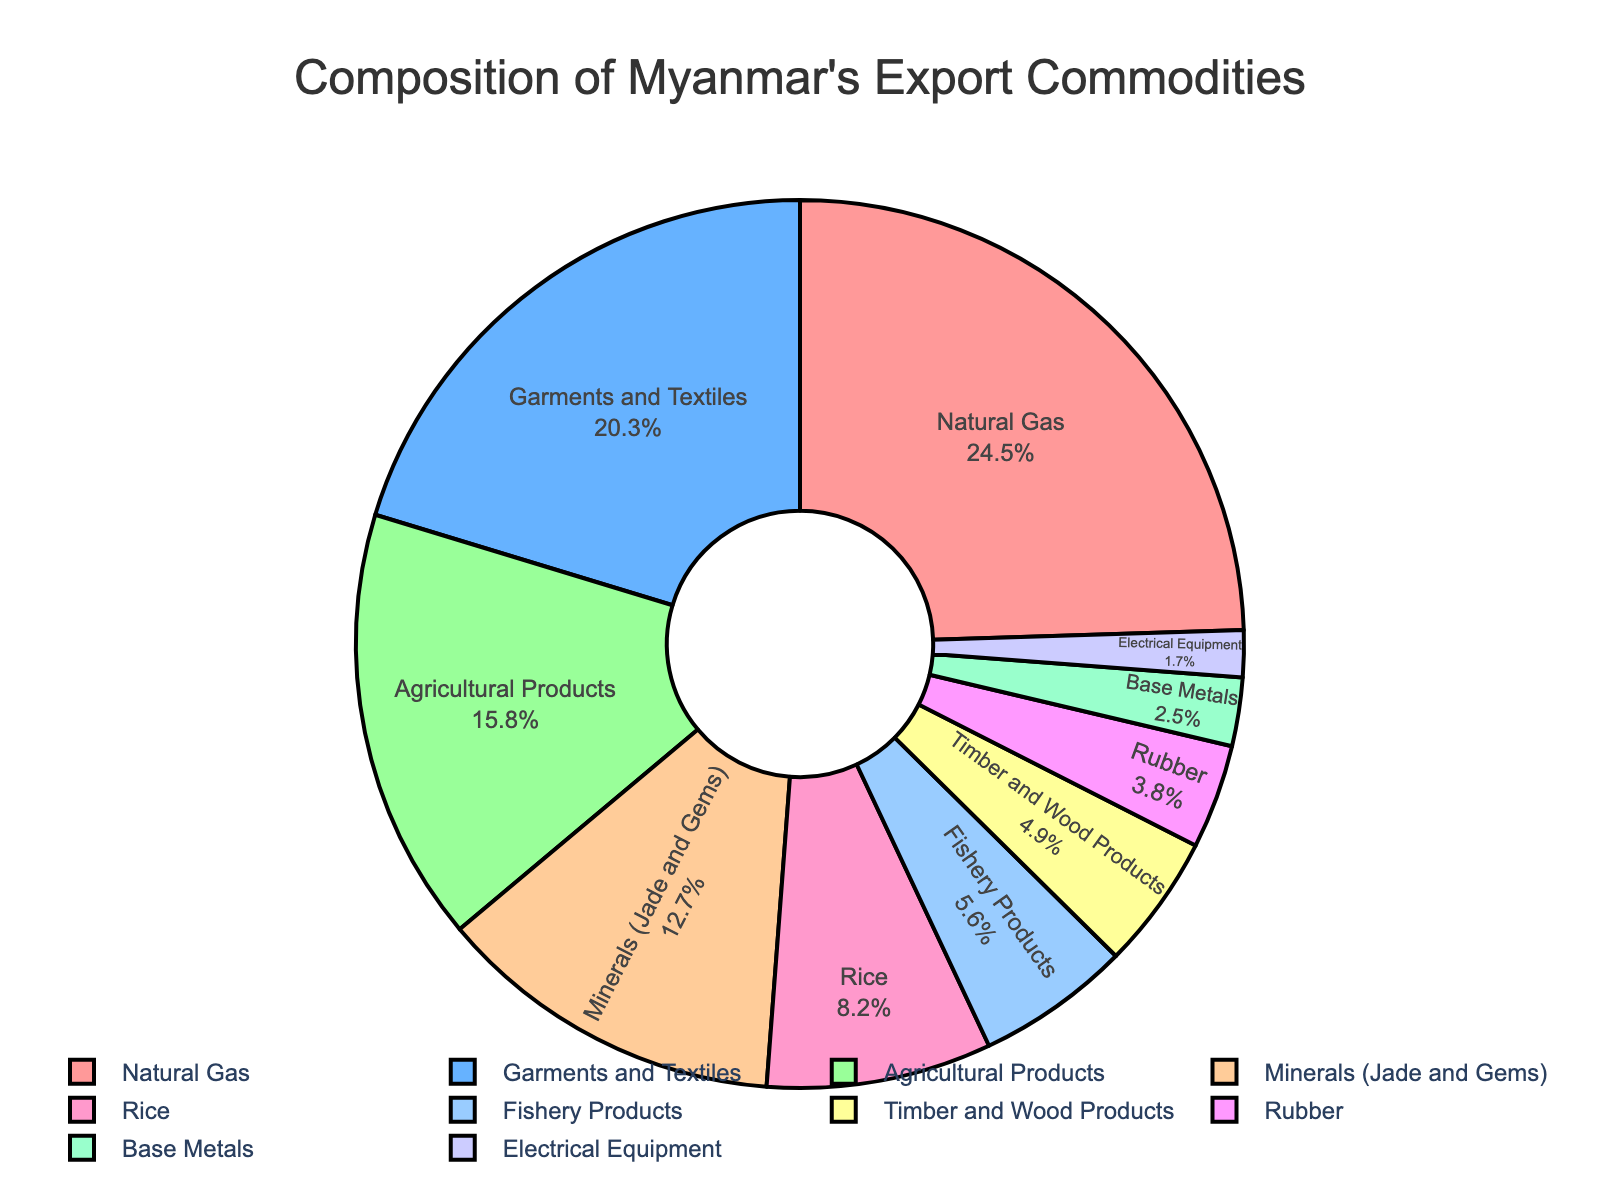What percentage of Myanmar's export commodities does Natural Gas represent? Natural Gas holds 24.5% of Myanmar's export commodities as shown in the figure.
Answer: 24.5% What is the combined percentage of Garments and Textiles and Agricultural Products in Myanmar's export commodities? Garments and Textiles are 20.3% and Agricultural Products are 15.8%. Adding them together: 20.3% + 15.8% = 36.1%.
Answer: 36.1% Which commodity has the smallest share in Myanmar's export commodities? Electrical Equipment has the smallest share at 1.7%, according to the figure.
Answer: Electrical Equipment How much larger is the percentage of Natural Gas compared to Electrical Equipment? Natural Gas is 24.5% and Electrical Equipment is 1.7%. The difference is: 24.5% - 1.7% = 22.8%.
Answer: 22.8% Which export commodity combined with Rice equals more than 20% of Myanmar's export commodities? Rice is 8.2%. Adding it to Timber and Wood Products (4.9%) gives 8.2% + 4.9% = 13.1%, not more than 20%. Adding Rice (8.2%) and Fishery Products (5.6%) gives 8.2% + 5.6% = 13.8%, not more than 20%. Adding Rice (8.2%) and Agricultural Products (15.8%) gives 8.2% + 15.8% = 24.0%, which is more than 20%.
Answer: Agricultural Products If Natural Gas and Garments and Textiles percentages are doubled, what would their combined percentage be? Doubling Natural Gas gives 24.5% * 2 = 49%. Doubling Garments and Textiles gives 20.3% * 2 = 40.6%. Their combined percentage is: 49% + 40.6% = 89.6%.
Answer: 89.6% Is the percentage of Rubber exports greater than twice the percentage of Electrical Equipment exports? Twice the percentage of Electrical Equipment is: 1.7% * 2 = 3.4%. Rubber is 3.8%, which is greater than 3.4%.
Answer: Yes Which commodity has a percentage in the range of 10% to 15%? Minerals (Jade and Gems) has a percentage of 12.7%, which falls in the range of 10% to 15%.
Answer: Minerals (Jade and Gems) 